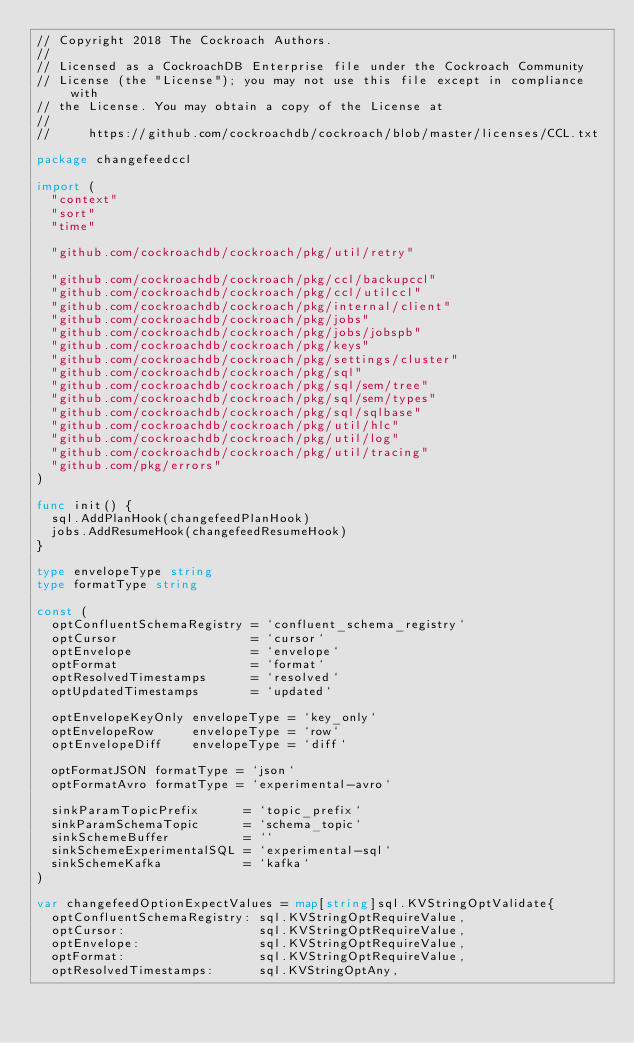<code> <loc_0><loc_0><loc_500><loc_500><_Go_>// Copyright 2018 The Cockroach Authors.
//
// Licensed as a CockroachDB Enterprise file under the Cockroach Community
// License (the "License"); you may not use this file except in compliance with
// the License. You may obtain a copy of the License at
//
//     https://github.com/cockroachdb/cockroach/blob/master/licenses/CCL.txt

package changefeedccl

import (
	"context"
	"sort"
	"time"

	"github.com/cockroachdb/cockroach/pkg/util/retry"

	"github.com/cockroachdb/cockroach/pkg/ccl/backupccl"
	"github.com/cockroachdb/cockroach/pkg/ccl/utilccl"
	"github.com/cockroachdb/cockroach/pkg/internal/client"
	"github.com/cockroachdb/cockroach/pkg/jobs"
	"github.com/cockroachdb/cockroach/pkg/jobs/jobspb"
	"github.com/cockroachdb/cockroach/pkg/keys"
	"github.com/cockroachdb/cockroach/pkg/settings/cluster"
	"github.com/cockroachdb/cockroach/pkg/sql"
	"github.com/cockroachdb/cockroach/pkg/sql/sem/tree"
	"github.com/cockroachdb/cockroach/pkg/sql/sem/types"
	"github.com/cockroachdb/cockroach/pkg/sql/sqlbase"
	"github.com/cockroachdb/cockroach/pkg/util/hlc"
	"github.com/cockroachdb/cockroach/pkg/util/log"
	"github.com/cockroachdb/cockroach/pkg/util/tracing"
	"github.com/pkg/errors"
)

func init() {
	sql.AddPlanHook(changefeedPlanHook)
	jobs.AddResumeHook(changefeedResumeHook)
}

type envelopeType string
type formatType string

const (
	optConfluentSchemaRegistry = `confluent_schema_registry`
	optCursor                  = `cursor`
	optEnvelope                = `envelope`
	optFormat                  = `format`
	optResolvedTimestamps      = `resolved`
	optUpdatedTimestamps       = `updated`

	optEnvelopeKeyOnly envelopeType = `key_only`
	optEnvelopeRow     envelopeType = `row`
	optEnvelopeDiff    envelopeType = `diff`

	optFormatJSON formatType = `json`
	optFormatAvro formatType = `experimental-avro`

	sinkParamTopicPrefix      = `topic_prefix`
	sinkParamSchemaTopic      = `schema_topic`
	sinkSchemeBuffer          = ``
	sinkSchemeExperimentalSQL = `experimental-sql`
	sinkSchemeKafka           = `kafka`
)

var changefeedOptionExpectValues = map[string]sql.KVStringOptValidate{
	optConfluentSchemaRegistry: sql.KVStringOptRequireValue,
	optCursor:                  sql.KVStringOptRequireValue,
	optEnvelope:                sql.KVStringOptRequireValue,
	optFormat:                  sql.KVStringOptRequireValue,
	optResolvedTimestamps:      sql.KVStringOptAny,</code> 